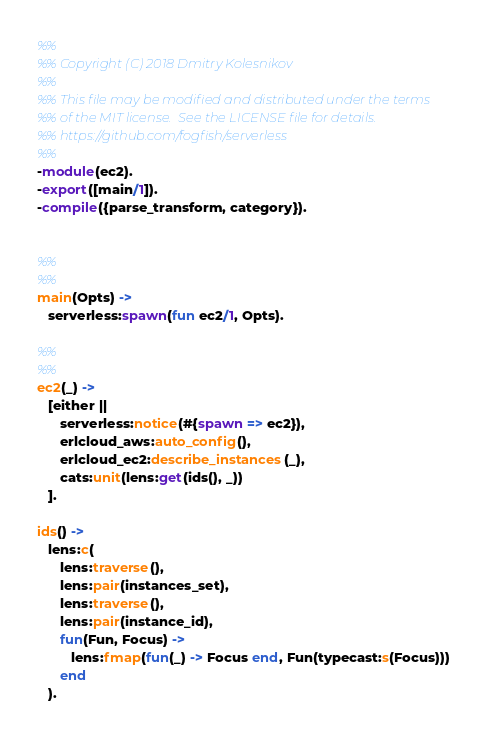<code> <loc_0><loc_0><loc_500><loc_500><_Erlang_>%%
%% Copyright (C) 2018 Dmitry Kolesnikov
%%
%% This file may be modified and distributed under the terms
%% of the MIT license.  See the LICENSE file for details.
%% https://github.com/fogfish/serverless
%%
-module(ec2).
-export([main/1]).
-compile({parse_transform, category}).


%%
%%
main(Opts) ->
   serverless:spawn(fun ec2/1, Opts).

%%
%%
ec2(_) ->
   [either ||
      serverless:notice(#{spawn => ec2}),
      erlcloud_aws:auto_config(),
      erlcloud_ec2:describe_instances(_),
      cats:unit(lens:get(ids(), _))
   ].

ids() ->
   lens:c(
      lens:traverse(),
      lens:pair(instances_set),
      lens:traverse(),
      lens:pair(instance_id),
      fun(Fun, Focus) ->
         lens:fmap(fun(_) -> Focus end, Fun(typecast:s(Focus)))
      end
   ).

</code> 